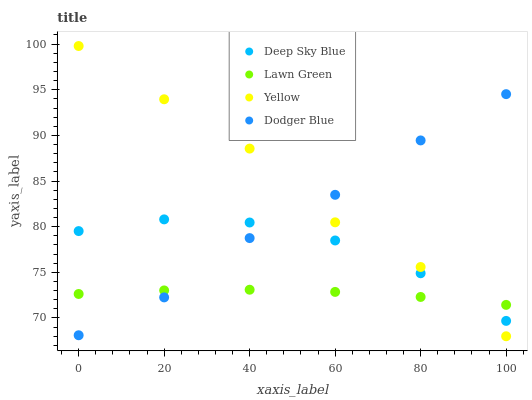Does Lawn Green have the minimum area under the curve?
Answer yes or no. Yes. Does Yellow have the maximum area under the curve?
Answer yes or no. Yes. Does Dodger Blue have the minimum area under the curve?
Answer yes or no. No. Does Dodger Blue have the maximum area under the curve?
Answer yes or no. No. Is Lawn Green the smoothest?
Answer yes or no. Yes. Is Yellow the roughest?
Answer yes or no. Yes. Is Dodger Blue the smoothest?
Answer yes or no. No. Is Dodger Blue the roughest?
Answer yes or no. No. Does Yellow have the lowest value?
Answer yes or no. Yes. Does Dodger Blue have the lowest value?
Answer yes or no. No. Does Yellow have the highest value?
Answer yes or no. Yes. Does Dodger Blue have the highest value?
Answer yes or no. No. Does Dodger Blue intersect Yellow?
Answer yes or no. Yes. Is Dodger Blue less than Yellow?
Answer yes or no. No. Is Dodger Blue greater than Yellow?
Answer yes or no. No. 